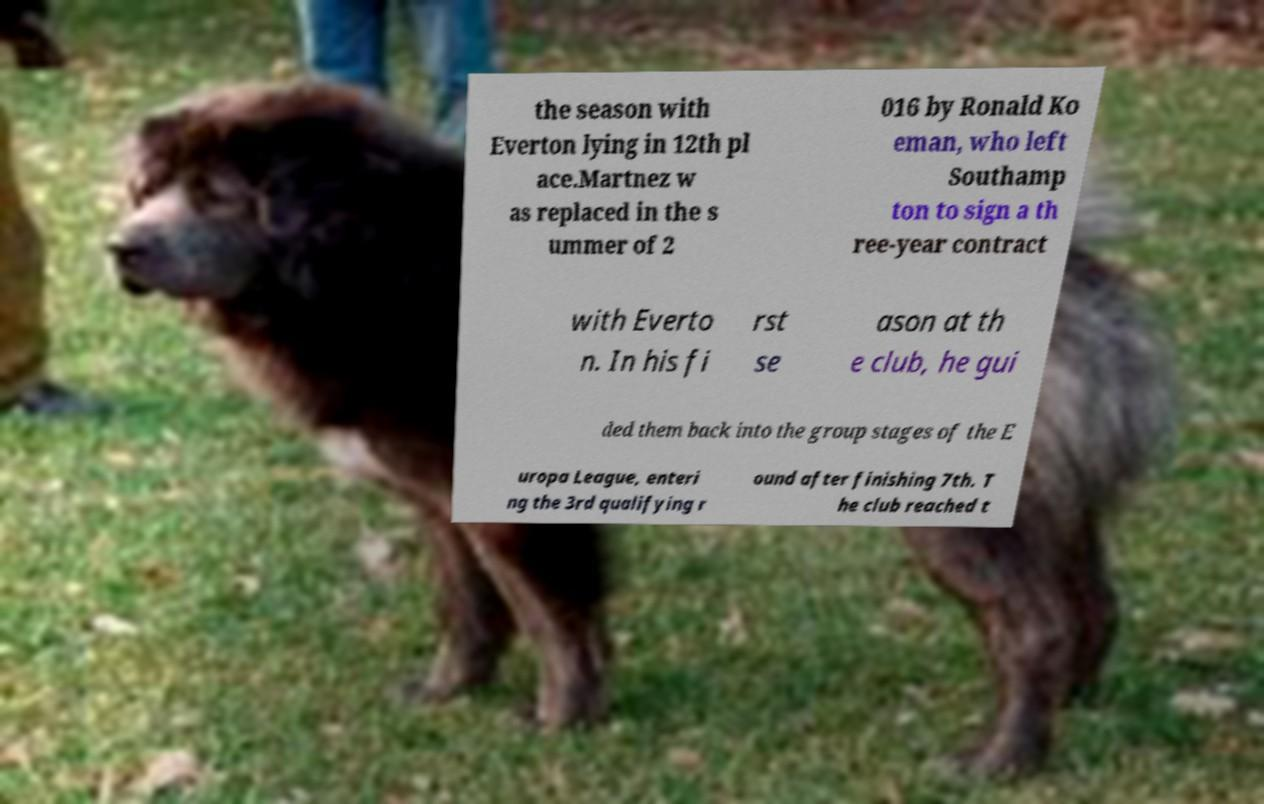There's text embedded in this image that I need extracted. Can you transcribe it verbatim? the season with Everton lying in 12th pl ace.Martnez w as replaced in the s ummer of 2 016 by Ronald Ko eman, who left Southamp ton to sign a th ree-year contract with Everto n. In his fi rst se ason at th e club, he gui ded them back into the group stages of the E uropa League, enteri ng the 3rd qualifying r ound after finishing 7th. T he club reached t 